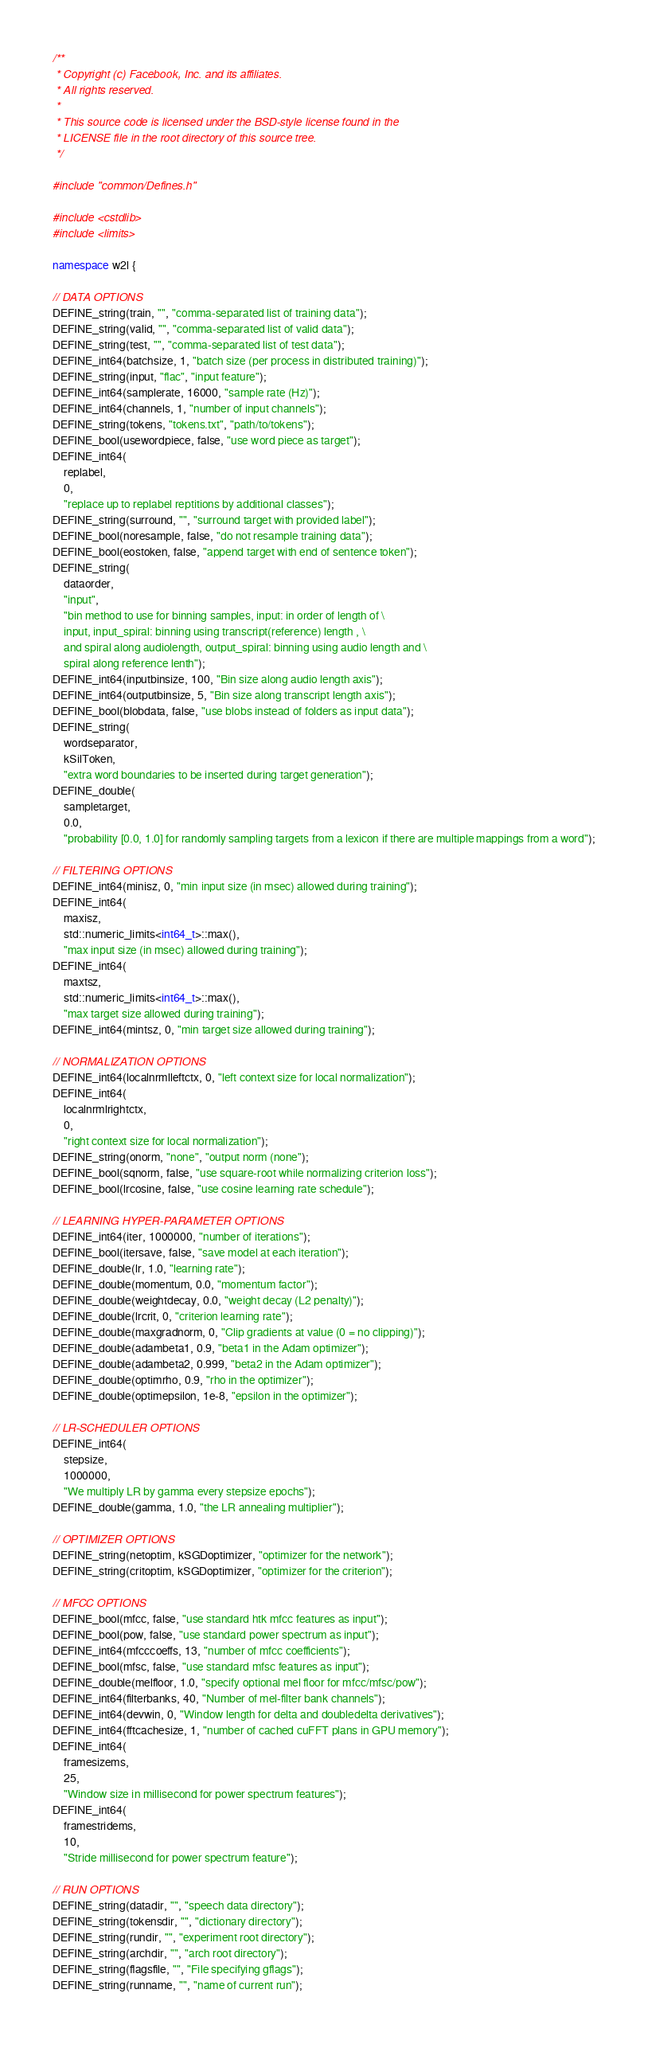<code> <loc_0><loc_0><loc_500><loc_500><_C++_>/**
 * Copyright (c) Facebook, Inc. and its affiliates.
 * All rights reserved.
 *
 * This source code is licensed under the BSD-style license found in the
 * LICENSE file in the root directory of this source tree.
 */

#include "common/Defines.h"

#include <cstdlib>
#include <limits>

namespace w2l {

// DATA OPTIONS
DEFINE_string(train, "", "comma-separated list of training data");
DEFINE_string(valid, "", "comma-separated list of valid data");
DEFINE_string(test, "", "comma-separated list of test data");
DEFINE_int64(batchsize, 1, "batch size (per process in distributed training)");
DEFINE_string(input, "flac", "input feature");
DEFINE_int64(samplerate, 16000, "sample rate (Hz)");
DEFINE_int64(channels, 1, "number of input channels");
DEFINE_string(tokens, "tokens.txt", "path/to/tokens");
DEFINE_bool(usewordpiece, false, "use word piece as target");
DEFINE_int64(
    replabel,
    0,
    "replace up to replabel reptitions by additional classes");
DEFINE_string(surround, "", "surround target with provided label");
DEFINE_bool(noresample, false, "do not resample training data");
DEFINE_bool(eostoken, false, "append target with end of sentence token");
DEFINE_string(
    dataorder,
    "input",
    "bin method to use for binning samples, input: in order of length of \
    input, input_spiral: binning using transcript(reference) length , \
    and spiral along audiolength, output_spiral: binning using audio length and \
    spiral along reference lenth");
DEFINE_int64(inputbinsize, 100, "Bin size along audio length axis");
DEFINE_int64(outputbinsize, 5, "Bin size along transcript length axis");
DEFINE_bool(blobdata, false, "use blobs instead of folders as input data");
DEFINE_string(
    wordseparator,
    kSilToken,
    "extra word boundaries to be inserted during target generation");
DEFINE_double(
    sampletarget,
    0.0,
    "probability [0.0, 1.0] for randomly sampling targets from a lexicon if there are multiple mappings from a word");

// FILTERING OPTIONS
DEFINE_int64(minisz, 0, "min input size (in msec) allowed during training");
DEFINE_int64(
    maxisz,
    std::numeric_limits<int64_t>::max(),
    "max input size (in msec) allowed during training");
DEFINE_int64(
    maxtsz,
    std::numeric_limits<int64_t>::max(),
    "max target size allowed during training");
DEFINE_int64(mintsz, 0, "min target size allowed during training");

// NORMALIZATION OPTIONS
DEFINE_int64(localnrmlleftctx, 0, "left context size for local normalization");
DEFINE_int64(
    localnrmlrightctx,
    0,
    "right context size for local normalization");
DEFINE_string(onorm, "none", "output norm (none");
DEFINE_bool(sqnorm, false, "use square-root while normalizing criterion loss");
DEFINE_bool(lrcosine, false, "use cosine learning rate schedule");

// LEARNING HYPER-PARAMETER OPTIONS
DEFINE_int64(iter, 1000000, "number of iterations");
DEFINE_bool(itersave, false, "save model at each iteration");
DEFINE_double(lr, 1.0, "learning rate");
DEFINE_double(momentum, 0.0, "momentum factor");
DEFINE_double(weightdecay, 0.0, "weight decay (L2 penalty)");
DEFINE_double(lrcrit, 0, "criterion learning rate");
DEFINE_double(maxgradnorm, 0, "Clip gradients at value (0 = no clipping)");
DEFINE_double(adambeta1, 0.9, "beta1 in the Adam optimizer");
DEFINE_double(adambeta2, 0.999, "beta2 in the Adam optimizer");
DEFINE_double(optimrho, 0.9, "rho in the optimizer");
DEFINE_double(optimepsilon, 1e-8, "epsilon in the optimizer");

// LR-SCHEDULER OPTIONS
DEFINE_int64(
    stepsize,
    1000000,
    "We multiply LR by gamma every stepsize epochs");
DEFINE_double(gamma, 1.0, "the LR annealing multiplier");

// OPTIMIZER OPTIONS
DEFINE_string(netoptim, kSGDoptimizer, "optimizer for the network");
DEFINE_string(critoptim, kSGDoptimizer, "optimizer for the criterion");

// MFCC OPTIONS
DEFINE_bool(mfcc, false, "use standard htk mfcc features as input");
DEFINE_bool(pow, false, "use standard power spectrum as input");
DEFINE_int64(mfcccoeffs, 13, "number of mfcc coefficients");
DEFINE_bool(mfsc, false, "use standard mfsc features as input");
DEFINE_double(melfloor, 1.0, "specify optional mel floor for mfcc/mfsc/pow");
DEFINE_int64(filterbanks, 40, "Number of mel-filter bank channels");
DEFINE_int64(devwin, 0, "Window length for delta and doubledelta derivatives");
DEFINE_int64(fftcachesize, 1, "number of cached cuFFT plans in GPU memory");
DEFINE_int64(
    framesizems,
    25,
    "Window size in millisecond for power spectrum features");
DEFINE_int64(
    framestridems,
    10,
    "Stride millisecond for power spectrum feature");

// RUN OPTIONS
DEFINE_string(datadir, "", "speech data directory");
DEFINE_string(tokensdir, "", "dictionary directory");
DEFINE_string(rundir, "", "experiment root directory");
DEFINE_string(archdir, "", "arch root directory");
DEFINE_string(flagsfile, "", "File specifying gflags");
DEFINE_string(runname, "", "name of current run");</code> 